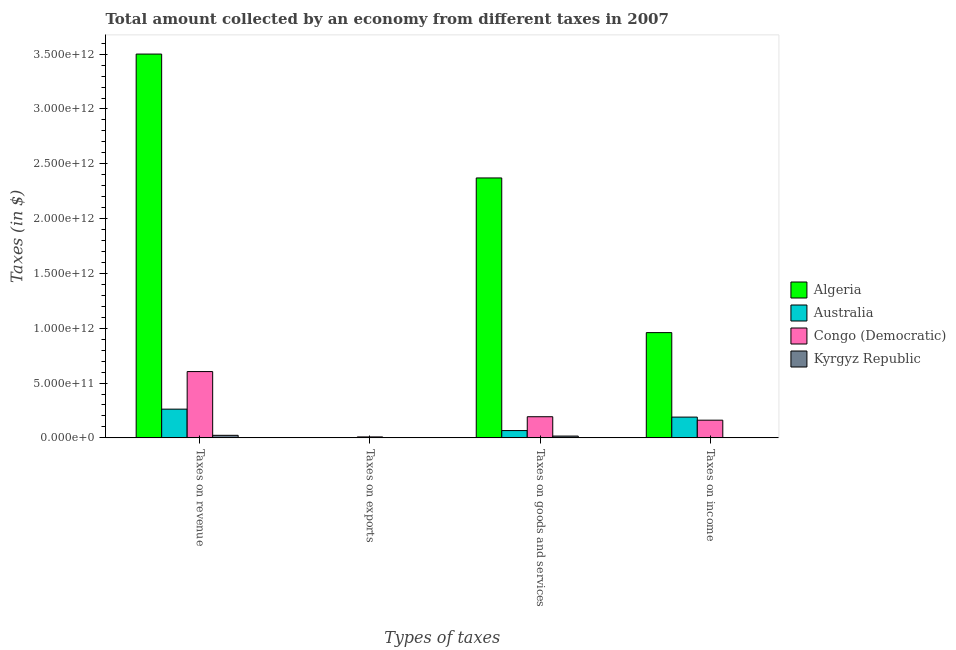How many different coloured bars are there?
Keep it short and to the point. 4. Are the number of bars per tick equal to the number of legend labels?
Offer a terse response. Yes. Are the number of bars on each tick of the X-axis equal?
Give a very brief answer. Yes. How many bars are there on the 4th tick from the right?
Offer a terse response. 4. What is the label of the 2nd group of bars from the left?
Your response must be concise. Taxes on exports. What is the amount collected as tax on exports in Kyrgyz Republic?
Your answer should be compact. 1.46e+05. Across all countries, what is the maximum amount collected as tax on income?
Your answer should be very brief. 9.60e+11. Across all countries, what is the minimum amount collected as tax on exports?
Keep it short and to the point. 1.46e+05. In which country was the amount collected as tax on income maximum?
Provide a succinct answer. Algeria. In which country was the amount collected as tax on income minimum?
Keep it short and to the point. Kyrgyz Republic. What is the total amount collected as tax on exports in the graph?
Offer a terse response. 8.77e+09. What is the difference between the amount collected as tax on income in Algeria and that in Kyrgyz Republic?
Your answer should be compact. 9.57e+11. What is the difference between the amount collected as tax on goods in Australia and the amount collected as tax on income in Algeria?
Make the answer very short. -8.93e+11. What is the average amount collected as tax on goods per country?
Offer a very short reply. 6.62e+11. What is the difference between the amount collected as tax on goods and amount collected as tax on exports in Congo (Democratic)?
Provide a short and direct response. 1.84e+11. What is the ratio of the amount collected as tax on exports in Algeria to that in Congo (Democratic)?
Offer a terse response. 0.01. Is the amount collected as tax on goods in Australia less than that in Kyrgyz Republic?
Offer a terse response. No. Is the difference between the amount collected as tax on revenue in Congo (Democratic) and Algeria greater than the difference between the amount collected as tax on income in Congo (Democratic) and Algeria?
Give a very brief answer. No. What is the difference between the highest and the second highest amount collected as tax on revenue?
Provide a succinct answer. 2.90e+12. What is the difference between the highest and the lowest amount collected as tax on revenue?
Your answer should be compact. 3.48e+12. Is the sum of the amount collected as tax on income in Algeria and Australia greater than the maximum amount collected as tax on goods across all countries?
Your answer should be compact. No. What does the 2nd bar from the left in Taxes on income represents?
Give a very brief answer. Australia. What does the 1st bar from the right in Taxes on revenue represents?
Offer a terse response. Kyrgyz Republic. What is the difference between two consecutive major ticks on the Y-axis?
Give a very brief answer. 5.00e+11. Are the values on the major ticks of Y-axis written in scientific E-notation?
Ensure brevity in your answer.  Yes. Does the graph contain grids?
Your response must be concise. No. Where does the legend appear in the graph?
Provide a short and direct response. Center right. How are the legend labels stacked?
Keep it short and to the point. Vertical. What is the title of the graph?
Offer a terse response. Total amount collected by an economy from different taxes in 2007. Does "Rwanda" appear as one of the legend labels in the graph?
Provide a short and direct response. No. What is the label or title of the X-axis?
Make the answer very short. Types of taxes. What is the label or title of the Y-axis?
Give a very brief answer. Taxes (in $). What is the Taxes (in $) in Algeria in Taxes on revenue?
Give a very brief answer. 3.50e+12. What is the Taxes (in $) in Australia in Taxes on revenue?
Make the answer very short. 2.62e+11. What is the Taxes (in $) of Congo (Democratic) in Taxes on revenue?
Your response must be concise. 6.05e+11. What is the Taxes (in $) of Kyrgyz Republic in Taxes on revenue?
Your response must be concise. 2.33e+1. What is the Taxes (in $) in Algeria in Taxes on exports?
Your response must be concise. 8.00e+07. What is the Taxes (in $) of Australia in Taxes on exports?
Offer a terse response. 1.40e+07. What is the Taxes (in $) in Congo (Democratic) in Taxes on exports?
Give a very brief answer. 8.68e+09. What is the Taxes (in $) in Kyrgyz Republic in Taxes on exports?
Your response must be concise. 1.46e+05. What is the Taxes (in $) in Algeria in Taxes on goods and services?
Your response must be concise. 2.37e+12. What is the Taxes (in $) in Australia in Taxes on goods and services?
Ensure brevity in your answer.  6.66e+1. What is the Taxes (in $) in Congo (Democratic) in Taxes on goods and services?
Ensure brevity in your answer.  1.93e+11. What is the Taxes (in $) in Kyrgyz Republic in Taxes on goods and services?
Your response must be concise. 1.64e+1. What is the Taxes (in $) in Algeria in Taxes on income?
Provide a short and direct response. 9.60e+11. What is the Taxes (in $) in Australia in Taxes on income?
Your answer should be very brief. 1.89e+11. What is the Taxes (in $) in Congo (Democratic) in Taxes on income?
Provide a succinct answer. 1.61e+11. What is the Taxes (in $) in Kyrgyz Republic in Taxes on income?
Keep it short and to the point. 3.04e+09. Across all Types of taxes, what is the maximum Taxes (in $) in Algeria?
Your response must be concise. 3.50e+12. Across all Types of taxes, what is the maximum Taxes (in $) in Australia?
Provide a succinct answer. 2.62e+11. Across all Types of taxes, what is the maximum Taxes (in $) in Congo (Democratic)?
Offer a very short reply. 6.05e+11. Across all Types of taxes, what is the maximum Taxes (in $) in Kyrgyz Republic?
Offer a very short reply. 2.33e+1. Across all Types of taxes, what is the minimum Taxes (in $) of Algeria?
Ensure brevity in your answer.  8.00e+07. Across all Types of taxes, what is the minimum Taxes (in $) of Australia?
Provide a succinct answer. 1.40e+07. Across all Types of taxes, what is the minimum Taxes (in $) of Congo (Democratic)?
Offer a very short reply. 8.68e+09. Across all Types of taxes, what is the minimum Taxes (in $) in Kyrgyz Republic?
Keep it short and to the point. 1.46e+05. What is the total Taxes (in $) in Algeria in the graph?
Your answer should be very brief. 6.83e+12. What is the total Taxes (in $) in Australia in the graph?
Keep it short and to the point. 5.18e+11. What is the total Taxes (in $) in Congo (Democratic) in the graph?
Provide a short and direct response. 9.68e+11. What is the total Taxes (in $) of Kyrgyz Republic in the graph?
Ensure brevity in your answer.  4.27e+1. What is the difference between the Taxes (in $) of Algeria in Taxes on revenue and that in Taxes on exports?
Your answer should be very brief. 3.50e+12. What is the difference between the Taxes (in $) in Australia in Taxes on revenue and that in Taxes on exports?
Your answer should be compact. 2.62e+11. What is the difference between the Taxes (in $) of Congo (Democratic) in Taxes on revenue and that in Taxes on exports?
Offer a terse response. 5.96e+11. What is the difference between the Taxes (in $) of Kyrgyz Republic in Taxes on revenue and that in Taxes on exports?
Ensure brevity in your answer.  2.33e+1. What is the difference between the Taxes (in $) of Algeria in Taxes on revenue and that in Taxes on goods and services?
Your answer should be very brief. 1.13e+12. What is the difference between the Taxes (in $) in Australia in Taxes on revenue and that in Taxes on goods and services?
Make the answer very short. 1.95e+11. What is the difference between the Taxes (in $) of Congo (Democratic) in Taxes on revenue and that in Taxes on goods and services?
Give a very brief answer. 4.12e+11. What is the difference between the Taxes (in $) of Kyrgyz Republic in Taxes on revenue and that in Taxes on goods and services?
Provide a short and direct response. 6.83e+09. What is the difference between the Taxes (in $) of Algeria in Taxes on revenue and that in Taxes on income?
Your answer should be very brief. 2.54e+12. What is the difference between the Taxes (in $) of Australia in Taxes on revenue and that in Taxes on income?
Your response must be concise. 7.26e+1. What is the difference between the Taxes (in $) in Congo (Democratic) in Taxes on revenue and that in Taxes on income?
Your response must be concise. 4.43e+11. What is the difference between the Taxes (in $) in Kyrgyz Republic in Taxes on revenue and that in Taxes on income?
Give a very brief answer. 2.02e+1. What is the difference between the Taxes (in $) in Algeria in Taxes on exports and that in Taxes on goods and services?
Provide a short and direct response. -2.37e+12. What is the difference between the Taxes (in $) of Australia in Taxes on exports and that in Taxes on goods and services?
Offer a very short reply. -6.66e+1. What is the difference between the Taxes (in $) in Congo (Democratic) in Taxes on exports and that in Taxes on goods and services?
Your response must be concise. -1.84e+11. What is the difference between the Taxes (in $) of Kyrgyz Republic in Taxes on exports and that in Taxes on goods and services?
Give a very brief answer. -1.64e+1. What is the difference between the Taxes (in $) in Algeria in Taxes on exports and that in Taxes on income?
Provide a succinct answer. -9.60e+11. What is the difference between the Taxes (in $) of Australia in Taxes on exports and that in Taxes on income?
Offer a very short reply. -1.89e+11. What is the difference between the Taxes (in $) of Congo (Democratic) in Taxes on exports and that in Taxes on income?
Your answer should be compact. -1.53e+11. What is the difference between the Taxes (in $) of Kyrgyz Republic in Taxes on exports and that in Taxes on income?
Ensure brevity in your answer.  -3.04e+09. What is the difference between the Taxes (in $) of Algeria in Taxes on goods and services and that in Taxes on income?
Your answer should be compact. 1.41e+12. What is the difference between the Taxes (in $) of Australia in Taxes on goods and services and that in Taxes on income?
Your answer should be very brief. -1.23e+11. What is the difference between the Taxes (in $) in Congo (Democratic) in Taxes on goods and services and that in Taxes on income?
Make the answer very short. 3.15e+1. What is the difference between the Taxes (in $) of Kyrgyz Republic in Taxes on goods and services and that in Taxes on income?
Your response must be concise. 1.34e+1. What is the difference between the Taxes (in $) in Algeria in Taxes on revenue and the Taxes (in $) in Australia in Taxes on exports?
Offer a very short reply. 3.50e+12. What is the difference between the Taxes (in $) in Algeria in Taxes on revenue and the Taxes (in $) in Congo (Democratic) in Taxes on exports?
Provide a short and direct response. 3.49e+12. What is the difference between the Taxes (in $) of Algeria in Taxes on revenue and the Taxes (in $) of Kyrgyz Republic in Taxes on exports?
Provide a short and direct response. 3.50e+12. What is the difference between the Taxes (in $) of Australia in Taxes on revenue and the Taxes (in $) of Congo (Democratic) in Taxes on exports?
Provide a succinct answer. 2.53e+11. What is the difference between the Taxes (in $) in Australia in Taxes on revenue and the Taxes (in $) in Kyrgyz Republic in Taxes on exports?
Provide a short and direct response. 2.62e+11. What is the difference between the Taxes (in $) of Congo (Democratic) in Taxes on revenue and the Taxes (in $) of Kyrgyz Republic in Taxes on exports?
Give a very brief answer. 6.05e+11. What is the difference between the Taxes (in $) of Algeria in Taxes on revenue and the Taxes (in $) of Australia in Taxes on goods and services?
Your response must be concise. 3.43e+12. What is the difference between the Taxes (in $) in Algeria in Taxes on revenue and the Taxes (in $) in Congo (Democratic) in Taxes on goods and services?
Ensure brevity in your answer.  3.31e+12. What is the difference between the Taxes (in $) of Algeria in Taxes on revenue and the Taxes (in $) of Kyrgyz Republic in Taxes on goods and services?
Offer a very short reply. 3.48e+12. What is the difference between the Taxes (in $) in Australia in Taxes on revenue and the Taxes (in $) in Congo (Democratic) in Taxes on goods and services?
Offer a very short reply. 6.91e+1. What is the difference between the Taxes (in $) of Australia in Taxes on revenue and the Taxes (in $) of Kyrgyz Republic in Taxes on goods and services?
Keep it short and to the point. 2.46e+11. What is the difference between the Taxes (in $) of Congo (Democratic) in Taxes on revenue and the Taxes (in $) of Kyrgyz Republic in Taxes on goods and services?
Provide a short and direct response. 5.88e+11. What is the difference between the Taxes (in $) of Algeria in Taxes on revenue and the Taxes (in $) of Australia in Taxes on income?
Your answer should be very brief. 3.31e+12. What is the difference between the Taxes (in $) of Algeria in Taxes on revenue and the Taxes (in $) of Congo (Democratic) in Taxes on income?
Provide a short and direct response. 3.34e+12. What is the difference between the Taxes (in $) of Algeria in Taxes on revenue and the Taxes (in $) of Kyrgyz Republic in Taxes on income?
Provide a short and direct response. 3.50e+12. What is the difference between the Taxes (in $) in Australia in Taxes on revenue and the Taxes (in $) in Congo (Democratic) in Taxes on income?
Keep it short and to the point. 1.01e+11. What is the difference between the Taxes (in $) in Australia in Taxes on revenue and the Taxes (in $) in Kyrgyz Republic in Taxes on income?
Provide a succinct answer. 2.59e+11. What is the difference between the Taxes (in $) of Congo (Democratic) in Taxes on revenue and the Taxes (in $) of Kyrgyz Republic in Taxes on income?
Your answer should be compact. 6.02e+11. What is the difference between the Taxes (in $) in Algeria in Taxes on exports and the Taxes (in $) in Australia in Taxes on goods and services?
Offer a terse response. -6.65e+1. What is the difference between the Taxes (in $) in Algeria in Taxes on exports and the Taxes (in $) in Congo (Democratic) in Taxes on goods and services?
Your answer should be compact. -1.93e+11. What is the difference between the Taxes (in $) of Algeria in Taxes on exports and the Taxes (in $) of Kyrgyz Republic in Taxes on goods and services?
Provide a succinct answer. -1.64e+1. What is the difference between the Taxes (in $) of Australia in Taxes on exports and the Taxes (in $) of Congo (Democratic) in Taxes on goods and services?
Make the answer very short. -1.93e+11. What is the difference between the Taxes (in $) of Australia in Taxes on exports and the Taxes (in $) of Kyrgyz Republic in Taxes on goods and services?
Your answer should be compact. -1.64e+1. What is the difference between the Taxes (in $) in Congo (Democratic) in Taxes on exports and the Taxes (in $) in Kyrgyz Republic in Taxes on goods and services?
Your answer should be very brief. -7.76e+09. What is the difference between the Taxes (in $) of Algeria in Taxes on exports and the Taxes (in $) of Australia in Taxes on income?
Your answer should be very brief. -1.89e+11. What is the difference between the Taxes (in $) in Algeria in Taxes on exports and the Taxes (in $) in Congo (Democratic) in Taxes on income?
Your answer should be compact. -1.61e+11. What is the difference between the Taxes (in $) in Algeria in Taxes on exports and the Taxes (in $) in Kyrgyz Republic in Taxes on income?
Keep it short and to the point. -2.96e+09. What is the difference between the Taxes (in $) of Australia in Taxes on exports and the Taxes (in $) of Congo (Democratic) in Taxes on income?
Offer a very short reply. -1.61e+11. What is the difference between the Taxes (in $) in Australia in Taxes on exports and the Taxes (in $) in Kyrgyz Republic in Taxes on income?
Offer a very short reply. -3.03e+09. What is the difference between the Taxes (in $) of Congo (Democratic) in Taxes on exports and the Taxes (in $) of Kyrgyz Republic in Taxes on income?
Provide a succinct answer. 5.64e+09. What is the difference between the Taxes (in $) in Algeria in Taxes on goods and services and the Taxes (in $) in Australia in Taxes on income?
Make the answer very short. 2.18e+12. What is the difference between the Taxes (in $) in Algeria in Taxes on goods and services and the Taxes (in $) in Congo (Democratic) in Taxes on income?
Keep it short and to the point. 2.21e+12. What is the difference between the Taxes (in $) of Algeria in Taxes on goods and services and the Taxes (in $) of Kyrgyz Republic in Taxes on income?
Keep it short and to the point. 2.37e+12. What is the difference between the Taxes (in $) in Australia in Taxes on goods and services and the Taxes (in $) in Congo (Democratic) in Taxes on income?
Offer a terse response. -9.48e+1. What is the difference between the Taxes (in $) of Australia in Taxes on goods and services and the Taxes (in $) of Kyrgyz Republic in Taxes on income?
Offer a terse response. 6.35e+1. What is the difference between the Taxes (in $) of Congo (Democratic) in Taxes on goods and services and the Taxes (in $) of Kyrgyz Republic in Taxes on income?
Your response must be concise. 1.90e+11. What is the average Taxes (in $) in Algeria per Types of taxes?
Provide a short and direct response. 1.71e+12. What is the average Taxes (in $) of Australia per Types of taxes?
Offer a terse response. 1.29e+11. What is the average Taxes (in $) of Congo (Democratic) per Types of taxes?
Provide a short and direct response. 2.42e+11. What is the average Taxes (in $) of Kyrgyz Republic per Types of taxes?
Ensure brevity in your answer.  1.07e+1. What is the difference between the Taxes (in $) of Algeria and Taxes (in $) of Australia in Taxes on revenue?
Your response must be concise. 3.24e+12. What is the difference between the Taxes (in $) of Algeria and Taxes (in $) of Congo (Democratic) in Taxes on revenue?
Make the answer very short. 2.90e+12. What is the difference between the Taxes (in $) of Algeria and Taxes (in $) of Kyrgyz Republic in Taxes on revenue?
Provide a succinct answer. 3.48e+12. What is the difference between the Taxes (in $) in Australia and Taxes (in $) in Congo (Democratic) in Taxes on revenue?
Ensure brevity in your answer.  -3.43e+11. What is the difference between the Taxes (in $) of Australia and Taxes (in $) of Kyrgyz Republic in Taxes on revenue?
Your answer should be very brief. 2.39e+11. What is the difference between the Taxes (in $) of Congo (Democratic) and Taxes (in $) of Kyrgyz Republic in Taxes on revenue?
Offer a terse response. 5.81e+11. What is the difference between the Taxes (in $) in Algeria and Taxes (in $) in Australia in Taxes on exports?
Keep it short and to the point. 6.60e+07. What is the difference between the Taxes (in $) of Algeria and Taxes (in $) of Congo (Democratic) in Taxes on exports?
Offer a very short reply. -8.60e+09. What is the difference between the Taxes (in $) in Algeria and Taxes (in $) in Kyrgyz Republic in Taxes on exports?
Make the answer very short. 7.99e+07. What is the difference between the Taxes (in $) of Australia and Taxes (in $) of Congo (Democratic) in Taxes on exports?
Provide a succinct answer. -8.67e+09. What is the difference between the Taxes (in $) of Australia and Taxes (in $) of Kyrgyz Republic in Taxes on exports?
Offer a terse response. 1.39e+07. What is the difference between the Taxes (in $) of Congo (Democratic) and Taxes (in $) of Kyrgyz Republic in Taxes on exports?
Keep it short and to the point. 8.68e+09. What is the difference between the Taxes (in $) in Algeria and Taxes (in $) in Australia in Taxes on goods and services?
Your answer should be very brief. 2.30e+12. What is the difference between the Taxes (in $) of Algeria and Taxes (in $) of Congo (Democratic) in Taxes on goods and services?
Provide a succinct answer. 2.18e+12. What is the difference between the Taxes (in $) in Algeria and Taxes (in $) in Kyrgyz Republic in Taxes on goods and services?
Keep it short and to the point. 2.35e+12. What is the difference between the Taxes (in $) of Australia and Taxes (in $) of Congo (Democratic) in Taxes on goods and services?
Offer a terse response. -1.26e+11. What is the difference between the Taxes (in $) of Australia and Taxes (in $) of Kyrgyz Republic in Taxes on goods and services?
Ensure brevity in your answer.  5.02e+1. What is the difference between the Taxes (in $) of Congo (Democratic) and Taxes (in $) of Kyrgyz Republic in Taxes on goods and services?
Give a very brief answer. 1.76e+11. What is the difference between the Taxes (in $) of Algeria and Taxes (in $) of Australia in Taxes on income?
Ensure brevity in your answer.  7.71e+11. What is the difference between the Taxes (in $) in Algeria and Taxes (in $) in Congo (Democratic) in Taxes on income?
Your answer should be very brief. 7.99e+11. What is the difference between the Taxes (in $) in Algeria and Taxes (in $) in Kyrgyz Republic in Taxes on income?
Keep it short and to the point. 9.57e+11. What is the difference between the Taxes (in $) of Australia and Taxes (in $) of Congo (Democratic) in Taxes on income?
Ensure brevity in your answer.  2.80e+1. What is the difference between the Taxes (in $) in Australia and Taxes (in $) in Kyrgyz Republic in Taxes on income?
Your response must be concise. 1.86e+11. What is the difference between the Taxes (in $) in Congo (Democratic) and Taxes (in $) in Kyrgyz Republic in Taxes on income?
Provide a short and direct response. 1.58e+11. What is the ratio of the Taxes (in $) in Algeria in Taxes on revenue to that in Taxes on exports?
Ensure brevity in your answer.  4.38e+04. What is the ratio of the Taxes (in $) of Australia in Taxes on revenue to that in Taxes on exports?
Offer a terse response. 1.87e+04. What is the ratio of the Taxes (in $) of Congo (Democratic) in Taxes on revenue to that in Taxes on exports?
Your answer should be compact. 69.68. What is the ratio of the Taxes (in $) of Kyrgyz Republic in Taxes on revenue to that in Taxes on exports?
Your response must be concise. 1.59e+05. What is the ratio of the Taxes (in $) in Algeria in Taxes on revenue to that in Taxes on goods and services?
Your response must be concise. 1.48. What is the ratio of the Taxes (in $) of Australia in Taxes on revenue to that in Taxes on goods and services?
Your answer should be very brief. 3.93. What is the ratio of the Taxes (in $) in Congo (Democratic) in Taxes on revenue to that in Taxes on goods and services?
Your answer should be very brief. 3.14. What is the ratio of the Taxes (in $) in Kyrgyz Republic in Taxes on revenue to that in Taxes on goods and services?
Your response must be concise. 1.42. What is the ratio of the Taxes (in $) of Algeria in Taxes on revenue to that in Taxes on income?
Offer a terse response. 3.65. What is the ratio of the Taxes (in $) in Australia in Taxes on revenue to that in Taxes on income?
Your answer should be very brief. 1.38. What is the ratio of the Taxes (in $) in Congo (Democratic) in Taxes on revenue to that in Taxes on income?
Give a very brief answer. 3.75. What is the ratio of the Taxes (in $) in Kyrgyz Republic in Taxes on revenue to that in Taxes on income?
Offer a very short reply. 7.65. What is the ratio of the Taxes (in $) of Congo (Democratic) in Taxes on exports to that in Taxes on goods and services?
Your answer should be compact. 0.04. What is the ratio of the Taxes (in $) in Algeria in Taxes on exports to that in Taxes on income?
Keep it short and to the point. 0. What is the ratio of the Taxes (in $) of Congo (Democratic) in Taxes on exports to that in Taxes on income?
Give a very brief answer. 0.05. What is the ratio of the Taxes (in $) in Algeria in Taxes on goods and services to that in Taxes on income?
Give a very brief answer. 2.47. What is the ratio of the Taxes (in $) of Australia in Taxes on goods and services to that in Taxes on income?
Provide a succinct answer. 0.35. What is the ratio of the Taxes (in $) of Congo (Democratic) in Taxes on goods and services to that in Taxes on income?
Your answer should be compact. 1.2. What is the ratio of the Taxes (in $) of Kyrgyz Republic in Taxes on goods and services to that in Taxes on income?
Keep it short and to the point. 5.41. What is the difference between the highest and the second highest Taxes (in $) in Algeria?
Your answer should be compact. 1.13e+12. What is the difference between the highest and the second highest Taxes (in $) of Australia?
Make the answer very short. 7.26e+1. What is the difference between the highest and the second highest Taxes (in $) in Congo (Democratic)?
Your response must be concise. 4.12e+11. What is the difference between the highest and the second highest Taxes (in $) in Kyrgyz Republic?
Your answer should be compact. 6.83e+09. What is the difference between the highest and the lowest Taxes (in $) of Algeria?
Provide a succinct answer. 3.50e+12. What is the difference between the highest and the lowest Taxes (in $) in Australia?
Keep it short and to the point. 2.62e+11. What is the difference between the highest and the lowest Taxes (in $) of Congo (Democratic)?
Offer a terse response. 5.96e+11. What is the difference between the highest and the lowest Taxes (in $) in Kyrgyz Republic?
Make the answer very short. 2.33e+1. 